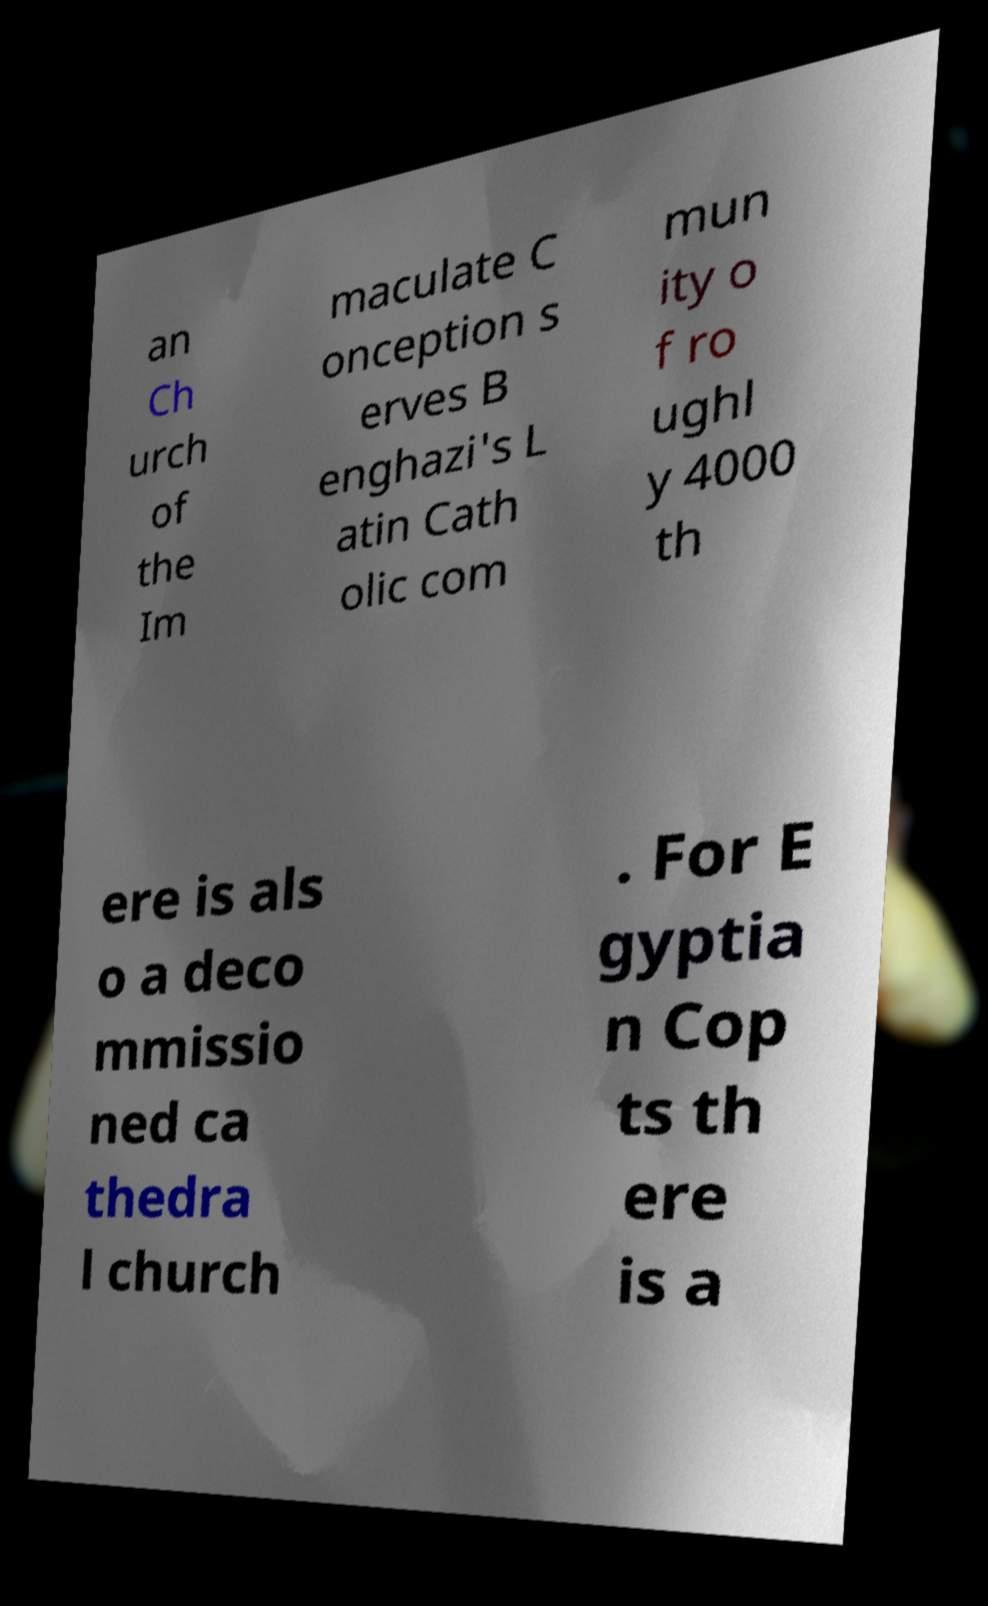Please identify and transcribe the text found in this image. an Ch urch of the Im maculate C onception s erves B enghazi's L atin Cath olic com mun ity o f ro ughl y 4000 th ere is als o a deco mmissio ned ca thedra l church . For E gyptia n Cop ts th ere is a 